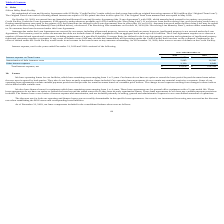According to Luna Innovations Incorporated's financial document, When was Original Term Loan matured and was repaid? According to the financial document, May 2019. The relevant text states: "The Original Term Loan matured and was repaid in May 2019...." Also, can you calculate: What is the change in Interest expense on Term Loans between December 31, 2018 and 2019? Based on the calculation: 8,073-101,087, the result is -93014. This is based on the information: "Interest expense on Term Loans $ 8,073 $ 101,087 Interest expense on Term Loans $ 8,073 $ 101,087..." The key data points involved are: 101,087, 8,073. Also, can you calculate: What is the average Interest expense on Term Loans for December 31, 2018 and 2019? To answer this question, I need to perform calculations using the financial data. The calculation is: (8,073+101,087) / 2, which equals 54580. This is based on the information: "Interest expense on Term Loans $ 8,073 $ 101,087 Interest expense on Term Loans $ 8,073 $ 101,087..." The key data points involved are: 101,087, 8,073. Additionally, In which year was Interest expense on Term Loans greater than 100,000? According to the financial document, 2018. The relevant text states: "se, net for the years ended December 31, 2019 and 2018 consisted of the following:..." Also, What was the Amortization of debt issuance costs in 2019 and 2018 respectively? The document shows two values: 5,685 and 16,308. From the document: "Amortization of debt issuance costs 5,685 16,308 Amortization of debt issuance costs 5,685 16,308..." Also, What was the Total interest expense, net in 2019 and 2018 respectively? The document shows two values: $15,878 and $124,344. From the document: "Total interest expense, net $ 15,878 $ 124,344 Total interest expense, net $ 15,878 $ 124,344..." 